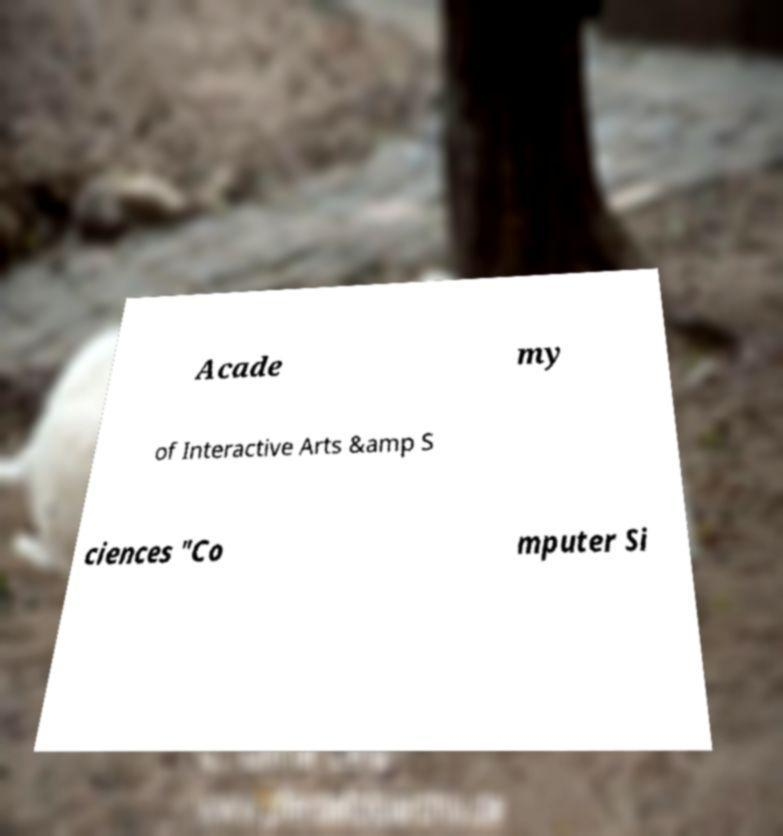For documentation purposes, I need the text within this image transcribed. Could you provide that? Acade my of Interactive Arts &amp S ciences "Co mputer Si 